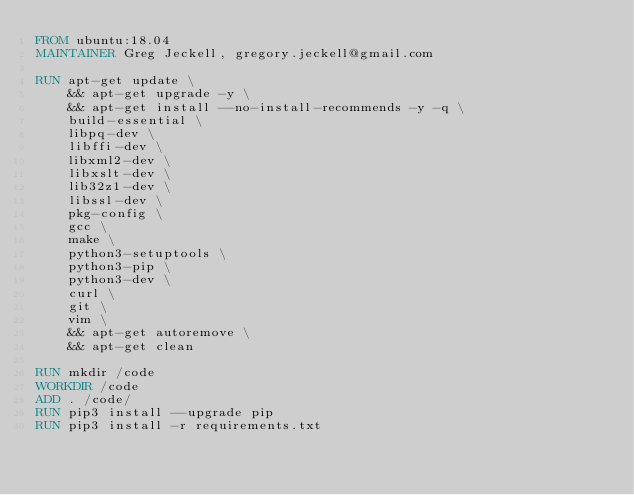Convert code to text. <code><loc_0><loc_0><loc_500><loc_500><_Dockerfile_>FROM ubuntu:18.04
MAINTAINER Greg Jeckell, gregory.jeckell@gmail.com

RUN apt-get update \
    && apt-get upgrade -y \
    && apt-get install --no-install-recommends -y -q \
    build-essential \
    libpq-dev \
    libffi-dev \
    libxml2-dev \
    libxslt-dev \
    lib32z1-dev \
    libssl-dev \
    pkg-config \
    gcc \
    make \
    python3-setuptools \
    python3-pip \
    python3-dev \
    curl \
    git \
    vim \
    && apt-get autoremove \
    && apt-get clean

RUN mkdir /code
WORKDIR /code
ADD . /code/
RUN pip3 install --upgrade pip
RUN pip3 install -r requirements.txt
</code> 